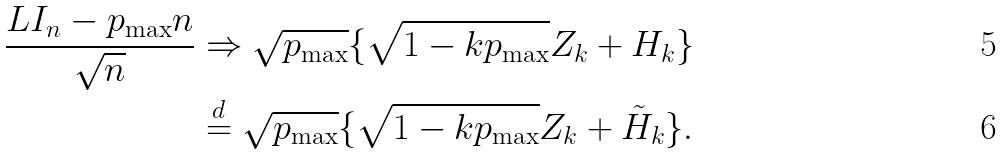Convert formula to latex. <formula><loc_0><loc_0><loc_500><loc_500>\frac { L I _ { n } - p _ { \max } n } { \sqrt { n } } & \Rightarrow \sqrt { p _ { \max } } \{ \sqrt { 1 - k p _ { \max } } Z _ { k } + H _ { k } \} \\ & \stackrel { d } { = } \sqrt { p _ { \max } } \{ \sqrt { 1 - k p _ { \max } } Z _ { k } + \tilde { H } _ { k } \} .</formula> 